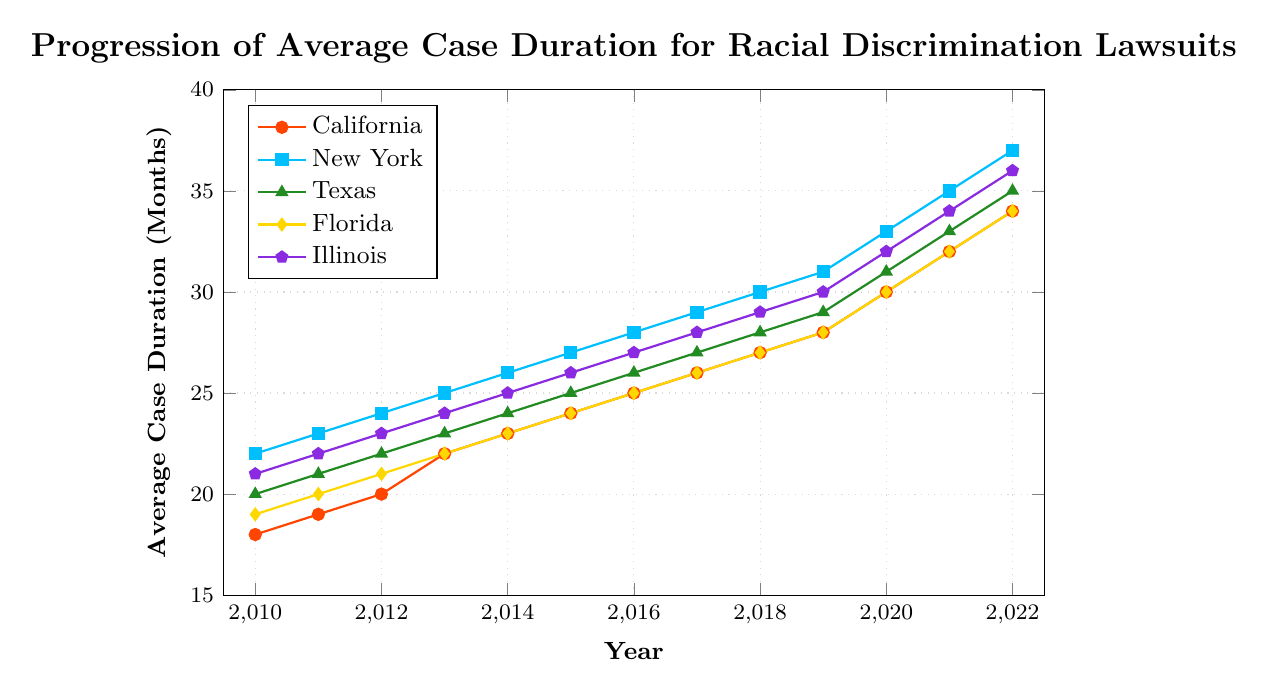Which state had the highest average case duration in 2022? Looking at the data for 2022, New York has the highest value, 37.
Answer: New York How did the average case duration in Florida change from 2010 to 2022? In 2010, Florida's average case duration was 19 months, and it increased to 34 months by 2022. The change is 34 - 19 = 15 months.
Answer: Increased by 15 months In which year did Texas surpass an average case duration of 30 months? Observing the line for Texas, it first surpasses 30 months in 2020.
Answer: 2020 Compare the average case duration in California and New York in 2015. Which is higher and by how much? In 2015, California had an average case duration of 24 months, while New York had 27 months. The difference is 27 - 24 = 3 months, with New York being higher.
Answer: New York, by 3 months What is the overall trend in average case duration for all states from 2010 to 2022? Across all the states, the lines show an upward trend from 2010 to 2022, indicating that the average case duration has been increasing.
Answer: Increasing What is the average case duration for Illinois in 2017? Referring to the data for Illinois in 2017, the duration was 28 months.
Answer: 28 months Which states had an average case duration of 34 months in 2022? Looking at the data for 2022, both California and Florida had an average case duration of 34 months.
Answer: California and Florida By how many months did the average case duration in New York increase from 2011 to 2016? In 2011, New York had an average case duration of 23 months, and it was 28 months in 2016. The increase is 28 - 23 = 5 months.
Answer: 5 months Estimate the difference in average case duration between Florida and Illinois in 2020. In 2020, Florida had an average case duration of 30 months, while Illinois had 32 months. The difference is 32 - 30 = 2 months.
Answer: 2 months 